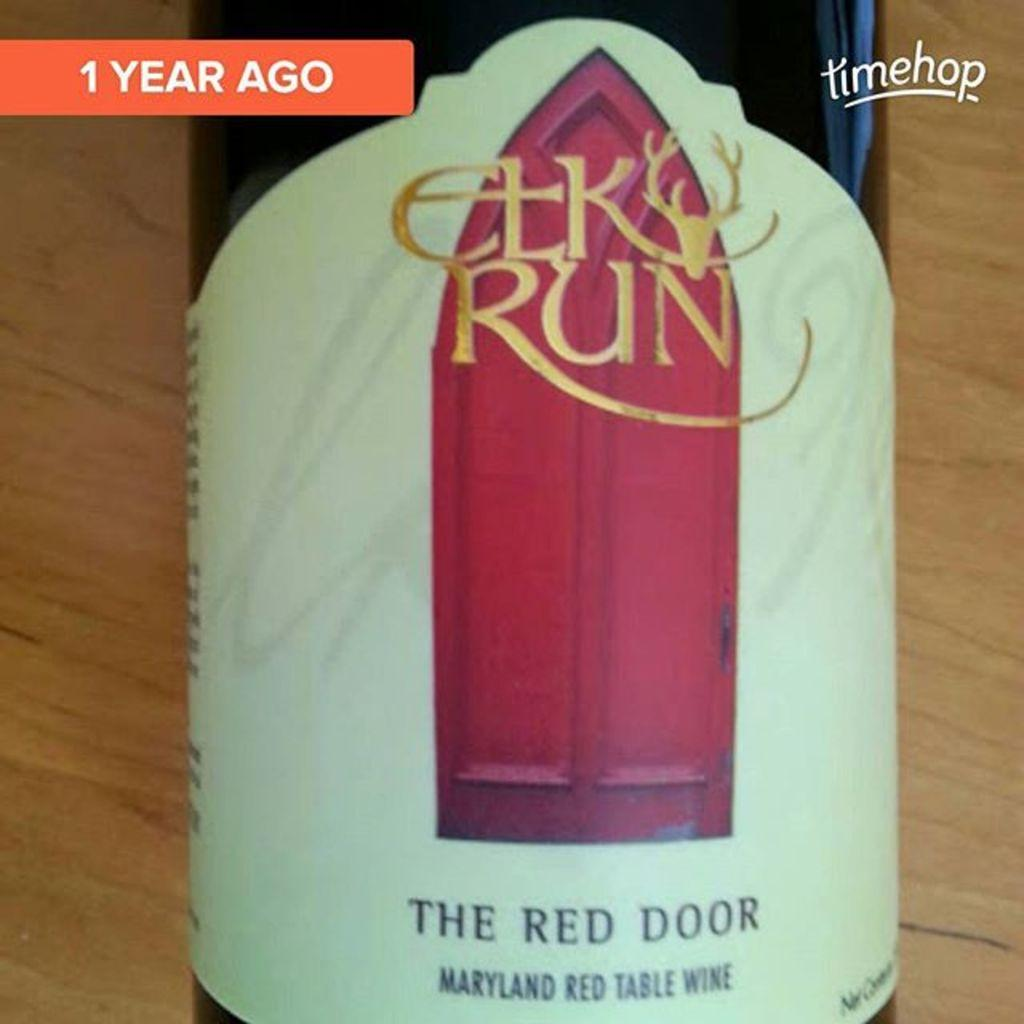Provide a one-sentence caption for the provided image. the front of a bottle of elk run the red door Maryland red table wind with a red door on the front . 